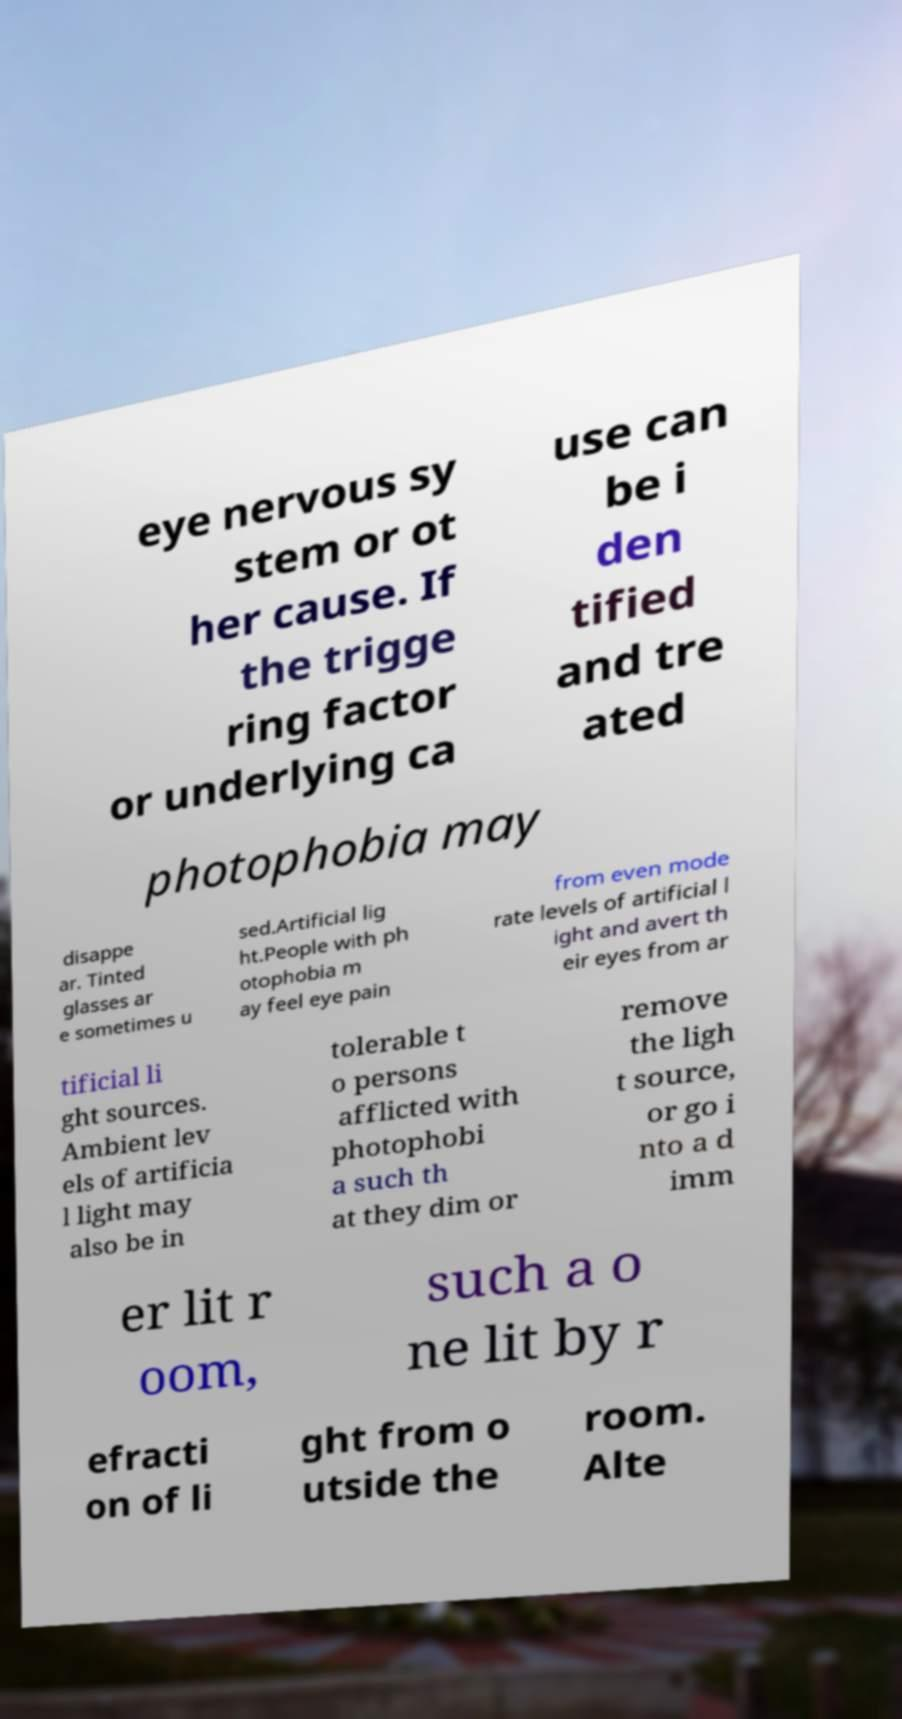What messages or text are displayed in this image? I need them in a readable, typed format. eye nervous sy stem or ot her cause. If the trigge ring factor or underlying ca use can be i den tified and tre ated photophobia may disappe ar. Tinted glasses ar e sometimes u sed.Artificial lig ht.People with ph otophobia m ay feel eye pain from even mode rate levels of artificial l ight and avert th eir eyes from ar tificial li ght sources. Ambient lev els of artificia l light may also be in tolerable t o persons afflicted with photophobi a such th at they dim or remove the ligh t source, or go i nto a d imm er lit r oom, such a o ne lit by r efracti on of li ght from o utside the room. Alte 